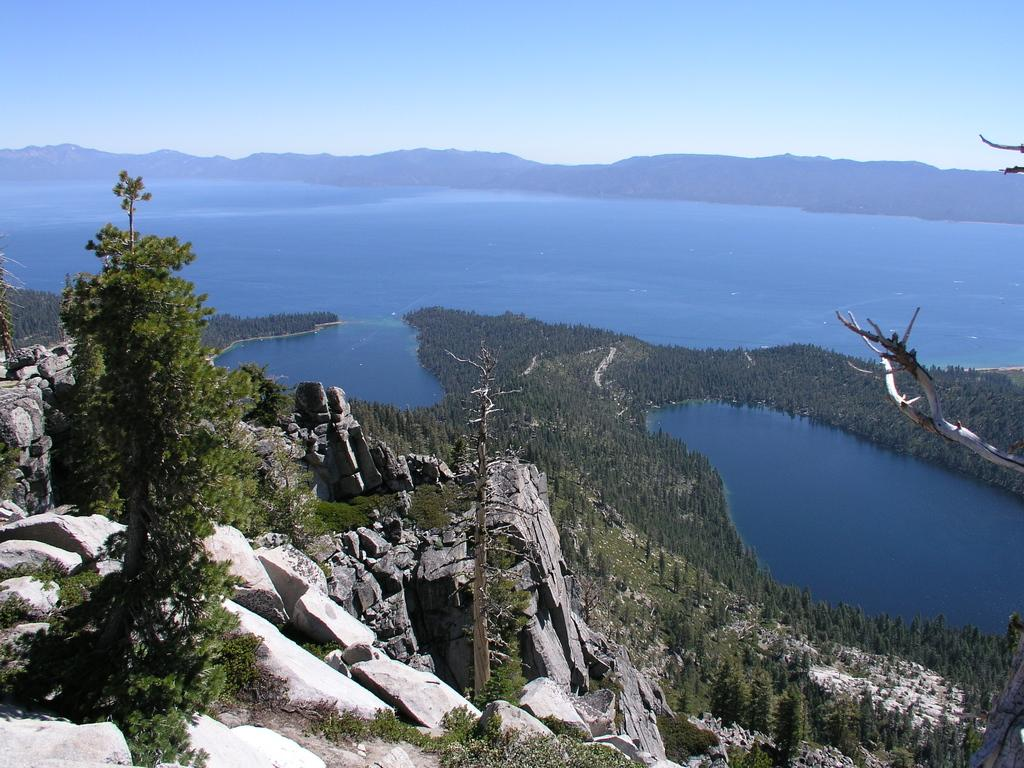What type of natural elements can be seen in the image? There are trees and plants in the image. What body of water is present in the image? There is a river in the image. How are the hills positioned in relation to the river? The river is located between hills. What is visible at the top of the image? The sky is visible at the top of the image. Can you tell me how many chairs are placed near the river in the image? There are no chairs present in the image; it features trees, plants, a river, and hills. What type of whip is being used to control the movement of the river in the image? There is no whip present in the image, and rivers do not require control or guidance. 